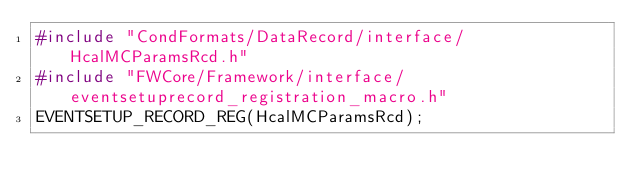<code> <loc_0><loc_0><loc_500><loc_500><_C++_>#include "CondFormats/DataRecord/interface/HcalMCParamsRcd.h"
#include "FWCore/Framework/interface/eventsetuprecord_registration_macro.h"
EVENTSETUP_RECORD_REG(HcalMCParamsRcd);
</code> 